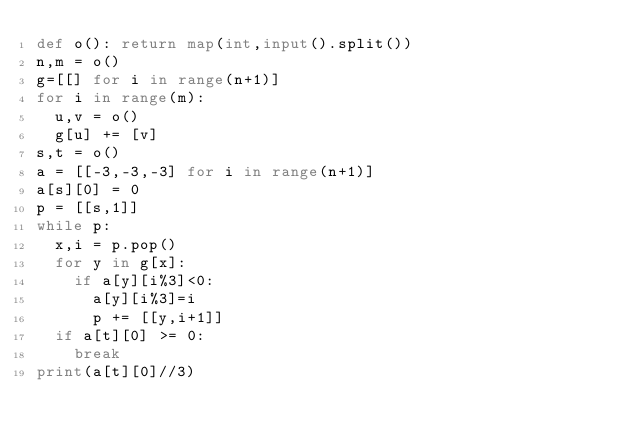<code> <loc_0><loc_0><loc_500><loc_500><_Python_>def o(): return map(int,input().split())
n,m = o()
g=[[] for i in range(n+1)]
for i in range(m):
  u,v = o()
  g[u] += [v]
s,t = o()
a = [[-3,-3,-3] for i in range(n+1)]
a[s][0] = 0
p = [[s,1]]
while p:
  x,i = p.pop()
  for y in g[x]:
    if a[y][i%3]<0:
      a[y][i%3]=i
      p += [[y,i+1]]
  if a[t][0] >= 0:
    break
print(a[t][0]//3)</code> 